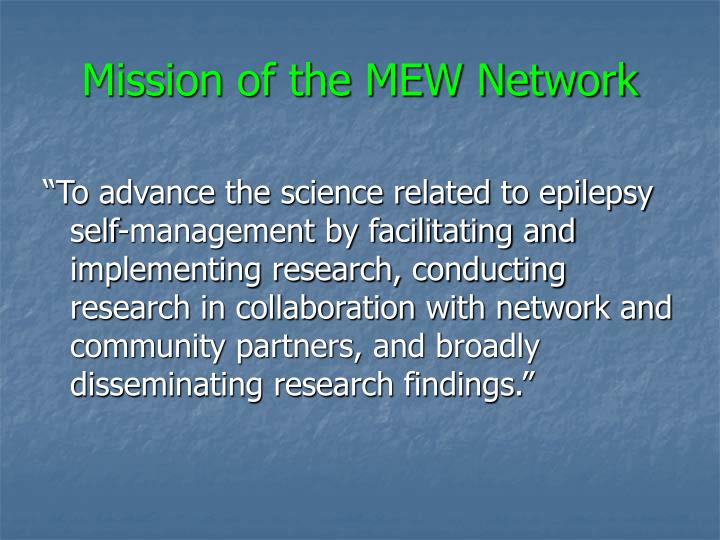What might be the primary area of focus for the MEW Network based on the mission statement? The MEW Network primarily focuses on enhancing the scientific framework around epilepsy self-management. Their mission involves not only facilitating and conducting critical research but also working collaboratively with network and community partners to ensure a multifaceted approach. This broad dissemination of research findings aims to create impactful, practical tools and knowledge bases that significantly improve self-management practices for individuals affected by epilepsy, leading to better day-to-day management and overall quality of life. 